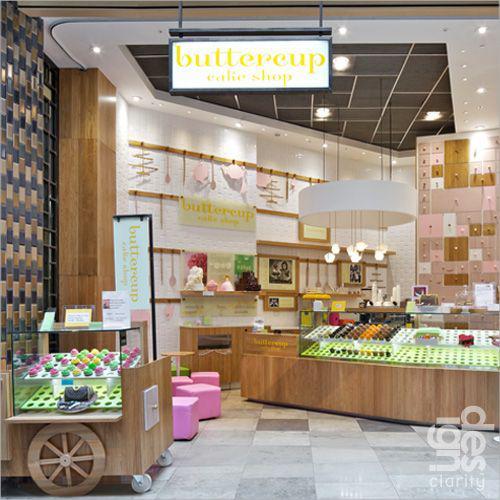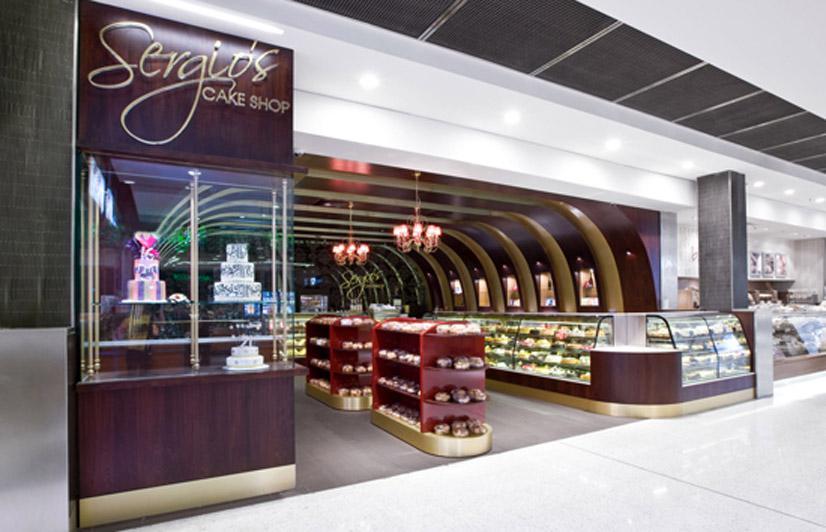The first image is the image on the left, the second image is the image on the right. Considering the images on both sides, is "There are at least five haning lights in the image on the right." valid? Answer yes or no. No. 